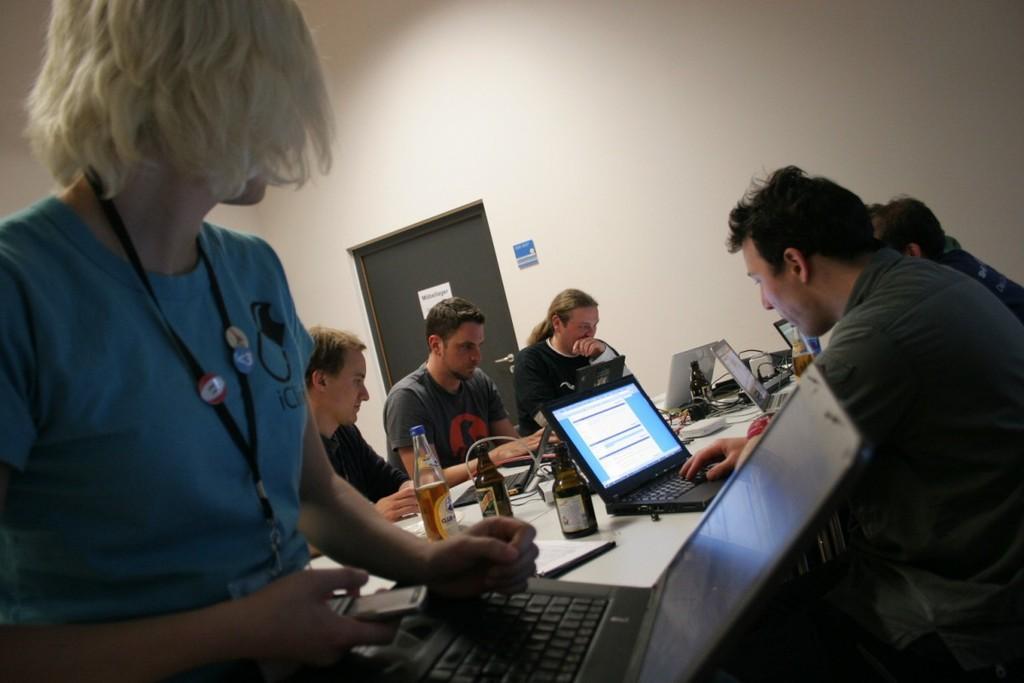Can you describe this image briefly? In this image we can see a few people, in front of them, we can see a table, on the table there are some laptops, bottles, cables and some other objects, in the background we can see a door and the wall. 